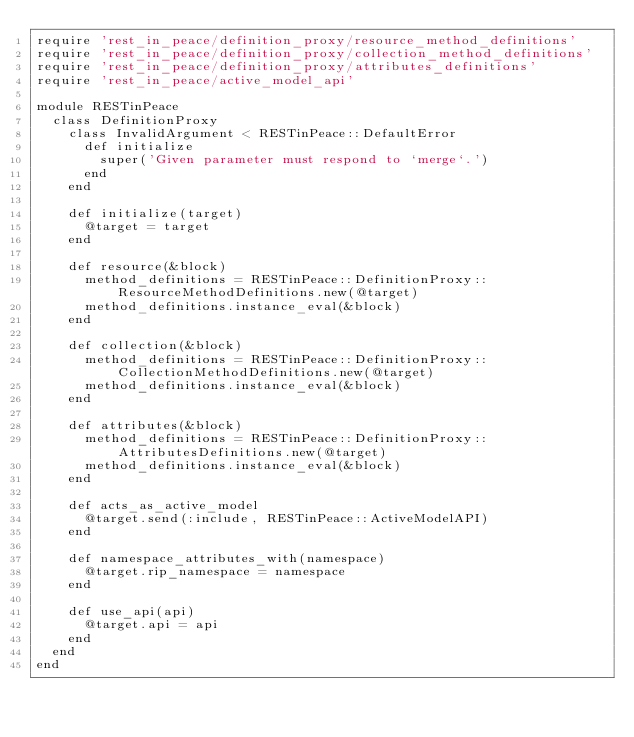Convert code to text. <code><loc_0><loc_0><loc_500><loc_500><_Ruby_>require 'rest_in_peace/definition_proxy/resource_method_definitions'
require 'rest_in_peace/definition_proxy/collection_method_definitions'
require 'rest_in_peace/definition_proxy/attributes_definitions'
require 'rest_in_peace/active_model_api'

module RESTinPeace
  class DefinitionProxy
    class InvalidArgument < RESTinPeace::DefaultError
      def initialize
        super('Given parameter must respond to `merge`.')
      end
    end

    def initialize(target)
      @target = target
    end

    def resource(&block)
      method_definitions = RESTinPeace::DefinitionProxy::ResourceMethodDefinitions.new(@target)
      method_definitions.instance_eval(&block)
    end

    def collection(&block)
      method_definitions = RESTinPeace::DefinitionProxy::CollectionMethodDefinitions.new(@target)
      method_definitions.instance_eval(&block)
    end

    def attributes(&block)
      method_definitions = RESTinPeace::DefinitionProxy::AttributesDefinitions.new(@target)
      method_definitions.instance_eval(&block)
    end

    def acts_as_active_model
      @target.send(:include, RESTinPeace::ActiveModelAPI)
    end

    def namespace_attributes_with(namespace)
      @target.rip_namespace = namespace
    end

    def use_api(api)
      @target.api = api
    end
  end
end
</code> 